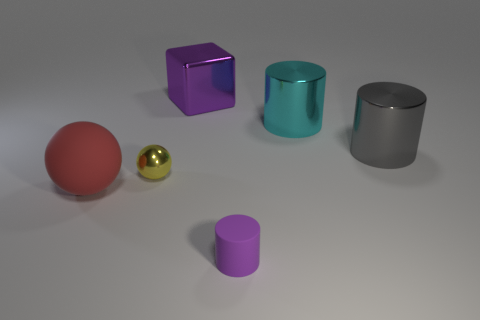Add 4 purple shiny things. How many objects exist? 10 Subtract all spheres. How many objects are left? 4 Add 3 green matte cylinders. How many green matte cylinders exist? 3 Subtract 0 brown blocks. How many objects are left? 6 Subtract all large shiny objects. Subtract all large red rubber objects. How many objects are left? 2 Add 1 shiny spheres. How many shiny spheres are left? 2 